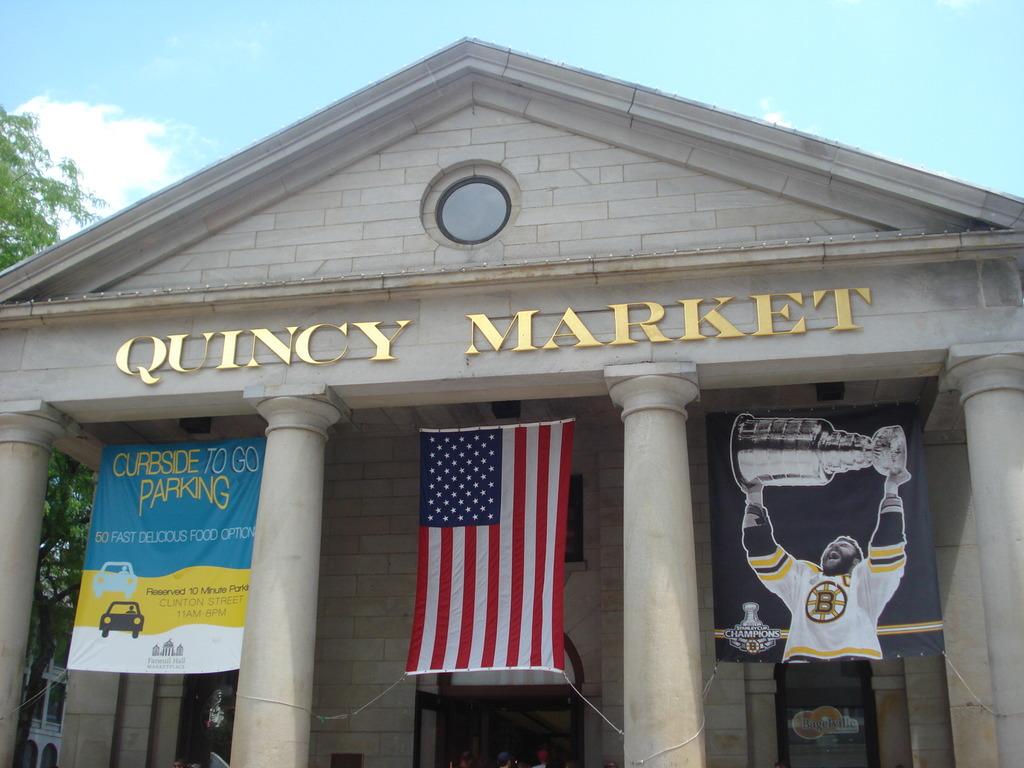What is quincy?
Offer a terse response. Market. 